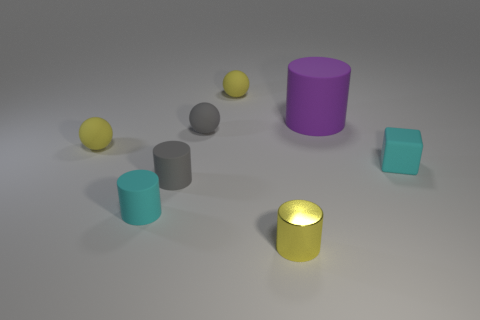How many objects are both left of the yellow metal thing and right of the shiny object?
Your answer should be compact. 0. What is the cyan object that is on the right side of the tiny yellow object in front of the small cyan rubber cylinder made of?
Ensure brevity in your answer.  Rubber. Is there a large brown ball made of the same material as the tiny yellow cylinder?
Your response must be concise. No. There is a cyan cylinder that is the same size as the yellow metallic cylinder; what material is it?
Give a very brief answer. Rubber. How big is the yellow rubber object to the right of the tiny yellow thing to the left of the tiny yellow rubber object on the right side of the tiny gray matte ball?
Make the answer very short. Small. There is a yellow object that is left of the small gray rubber cylinder; is there a object in front of it?
Give a very brief answer. Yes. Does the yellow metal object have the same shape as the small object that is to the right of the yellow cylinder?
Make the answer very short. No. What is the color of the tiny rubber cylinder that is behind the cyan cylinder?
Your answer should be compact. Gray. What is the size of the cyan thing behind the cyan thing that is in front of the small cyan matte block?
Your response must be concise. Small. Is the shape of the cyan thing in front of the tiny block the same as  the purple rubber object?
Provide a short and direct response. Yes. 